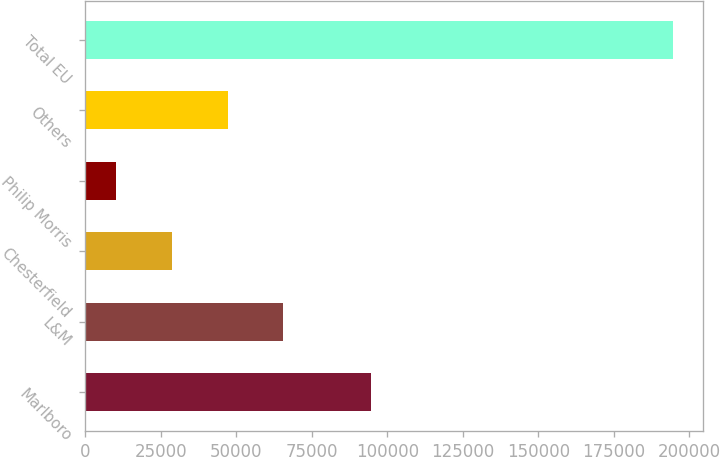Convert chart. <chart><loc_0><loc_0><loc_500><loc_500><bar_chart><fcel>Marlboro<fcel>L&M<fcel>Chesterfield<fcel>Philip Morris<fcel>Others<fcel>Total EU<nl><fcel>94537<fcel>65580.6<fcel>28676.2<fcel>10224<fcel>47128.4<fcel>194746<nl></chart> 